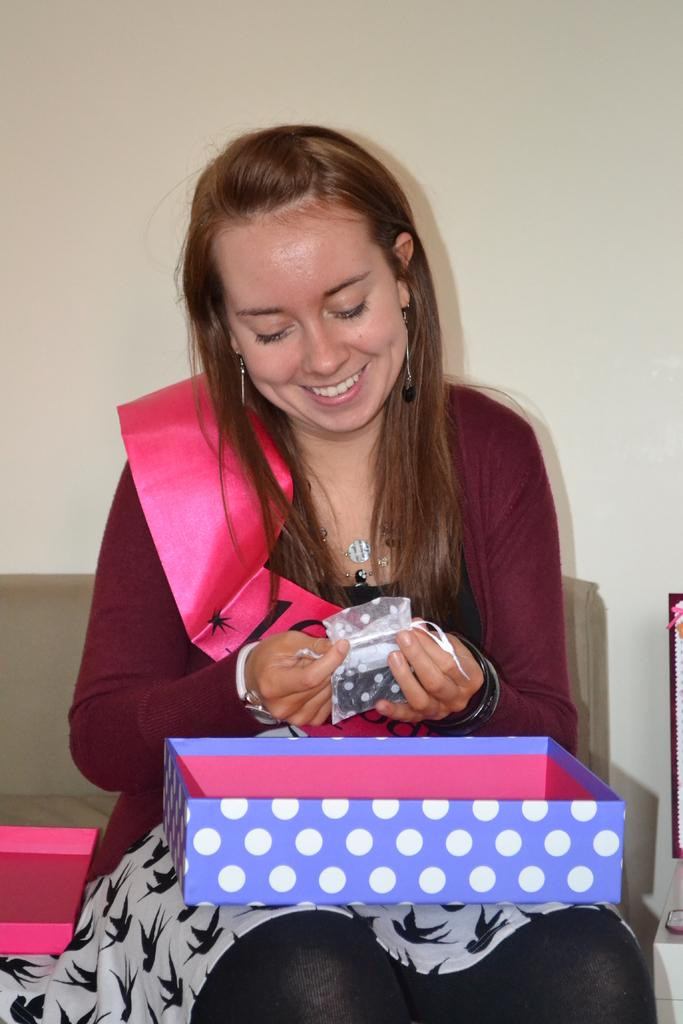Who is in the image? There is a woman in the image. What is the woman doing in the image? The woman is sitting. What objects is the woman holding in the image? The woman is holding a cover and a cardboard box. What can be seen in the background of the image? There is a couch and a wall in the background of the image. What type of smile can be seen on the woman's face in the image? There is no smile visible on the woman's face in the image. What is the mass of the cardboard box the woman is holding in the image? The mass of the cardboard box cannot be determined from the image alone. 